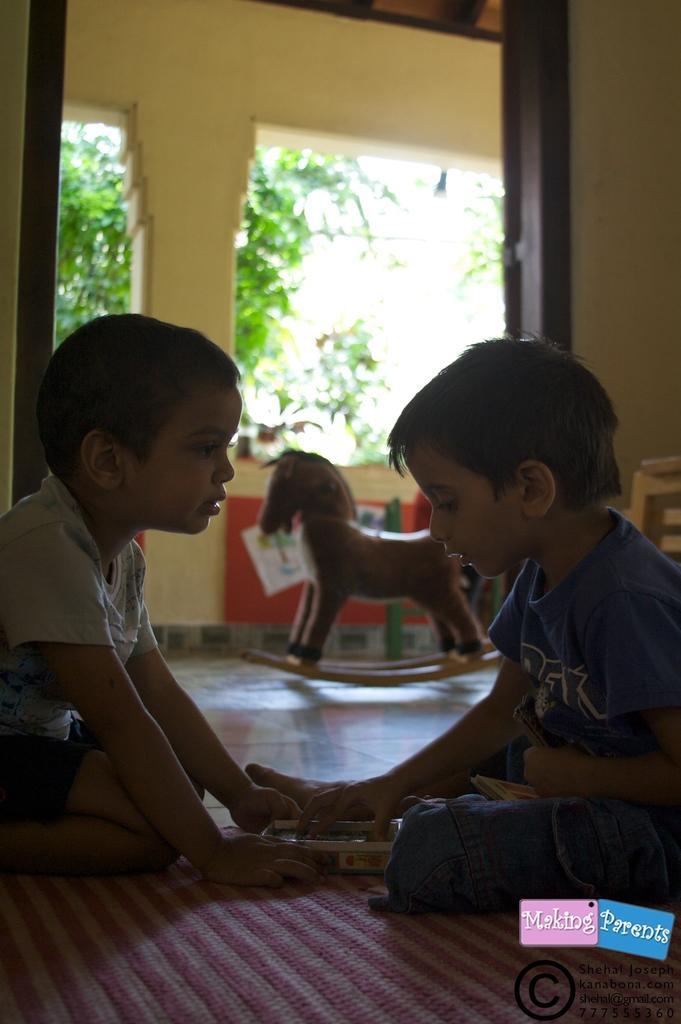How would you summarize this image in a sentence or two? On the bottom right, there is a watermark. On the right side, there is a person in a T-shirt, holding an object which is in a box. This box is on a mat. On the left side, there is a child, kneeling down on the mat and holding this box. In the background, there is a yellow wall color, there are trees and there are other objects. 